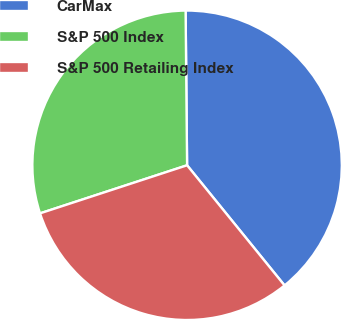Convert chart. <chart><loc_0><loc_0><loc_500><loc_500><pie_chart><fcel>CarMax<fcel>S&P 500 Index<fcel>S&P 500 Retailing Index<nl><fcel>39.31%<fcel>29.88%<fcel>30.82%<nl></chart> 